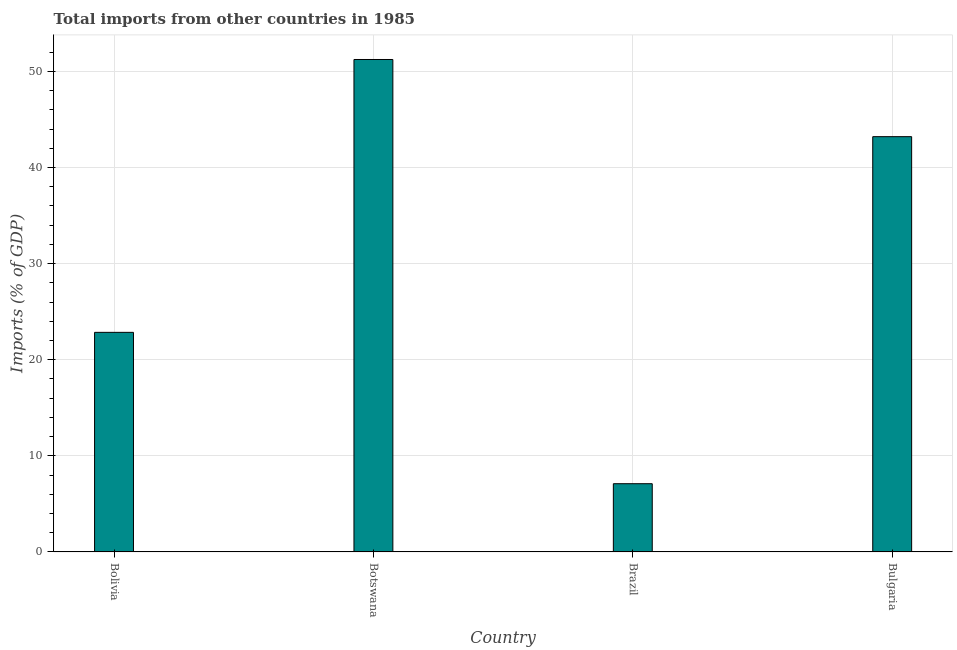Does the graph contain any zero values?
Your response must be concise. No. Does the graph contain grids?
Make the answer very short. Yes. What is the title of the graph?
Ensure brevity in your answer.  Total imports from other countries in 1985. What is the label or title of the Y-axis?
Your response must be concise. Imports (% of GDP). What is the total imports in Bulgaria?
Your answer should be very brief. 43.2. Across all countries, what is the maximum total imports?
Offer a very short reply. 51.23. Across all countries, what is the minimum total imports?
Provide a succinct answer. 7.1. In which country was the total imports maximum?
Keep it short and to the point. Botswana. What is the sum of the total imports?
Offer a terse response. 124.37. What is the difference between the total imports in Botswana and Brazil?
Your response must be concise. 44.14. What is the average total imports per country?
Your answer should be compact. 31.09. What is the median total imports?
Give a very brief answer. 33.02. In how many countries, is the total imports greater than 40 %?
Your response must be concise. 2. What is the ratio of the total imports in Brazil to that in Bulgaria?
Give a very brief answer. 0.16. Is the difference between the total imports in Botswana and Brazil greater than the difference between any two countries?
Make the answer very short. Yes. What is the difference between the highest and the second highest total imports?
Your response must be concise. 8.03. Is the sum of the total imports in Brazil and Bulgaria greater than the maximum total imports across all countries?
Keep it short and to the point. No. What is the difference between the highest and the lowest total imports?
Provide a succinct answer. 44.14. How many bars are there?
Offer a terse response. 4. Are all the bars in the graph horizontal?
Make the answer very short. No. What is the Imports (% of GDP) of Bolivia?
Keep it short and to the point. 22.84. What is the Imports (% of GDP) in Botswana?
Your response must be concise. 51.23. What is the Imports (% of GDP) in Brazil?
Provide a succinct answer. 7.1. What is the Imports (% of GDP) in Bulgaria?
Make the answer very short. 43.2. What is the difference between the Imports (% of GDP) in Bolivia and Botswana?
Your answer should be compact. -28.39. What is the difference between the Imports (% of GDP) in Bolivia and Brazil?
Provide a short and direct response. 15.75. What is the difference between the Imports (% of GDP) in Bolivia and Bulgaria?
Provide a succinct answer. -20.36. What is the difference between the Imports (% of GDP) in Botswana and Brazil?
Offer a very short reply. 44.14. What is the difference between the Imports (% of GDP) in Botswana and Bulgaria?
Give a very brief answer. 8.03. What is the difference between the Imports (% of GDP) in Brazil and Bulgaria?
Offer a terse response. -36.11. What is the ratio of the Imports (% of GDP) in Bolivia to that in Botswana?
Your answer should be very brief. 0.45. What is the ratio of the Imports (% of GDP) in Bolivia to that in Brazil?
Make the answer very short. 3.22. What is the ratio of the Imports (% of GDP) in Bolivia to that in Bulgaria?
Ensure brevity in your answer.  0.53. What is the ratio of the Imports (% of GDP) in Botswana to that in Brazil?
Give a very brief answer. 7.22. What is the ratio of the Imports (% of GDP) in Botswana to that in Bulgaria?
Provide a succinct answer. 1.19. What is the ratio of the Imports (% of GDP) in Brazil to that in Bulgaria?
Provide a short and direct response. 0.16. 